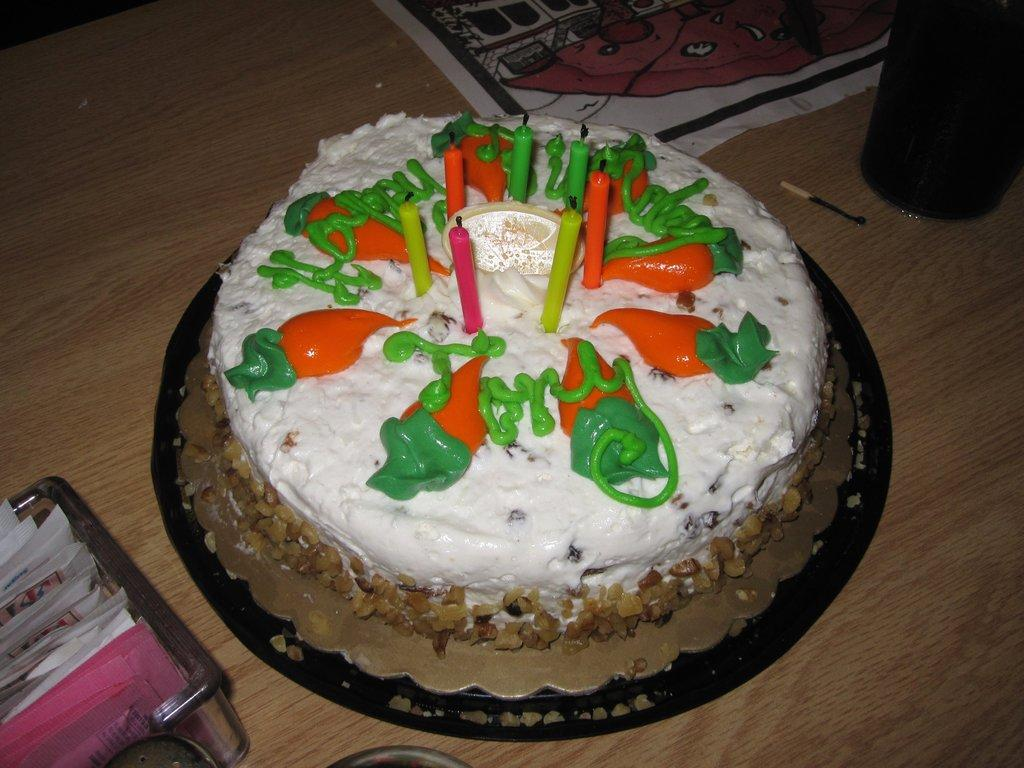What is the main object on the table in the image? There is a birthday cake on a table in the image. What is placed under the birthday cake? There is a table mat on the table. What other objects can be seen on the table? There is a match stick, a cup, and a tray with some papers on the table. Are there any dinosaurs visible in the image? No, there are no dinosaurs present in the image. Can you see a home in the image? The image does not show a home; it only shows objects on a table. 